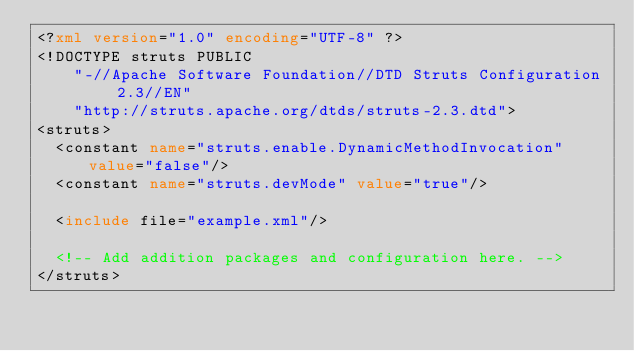<code> <loc_0><loc_0><loc_500><loc_500><_XML_><?xml version="1.0" encoding="UTF-8" ?>
<!DOCTYPE struts PUBLIC
	"-//Apache Software Foundation//DTD Struts Configuration 2.3//EN"
	"http://struts.apache.org/dtds/struts-2.3.dtd">
<struts>
  <constant name="struts.enable.DynamicMethodInvocation" value="false"/>
  <constant name="struts.devMode" value="true"/>
  
  <include file="example.xml"/>
  
  <!-- Add addition packages and configuration here. -->
</struts>
</code> 